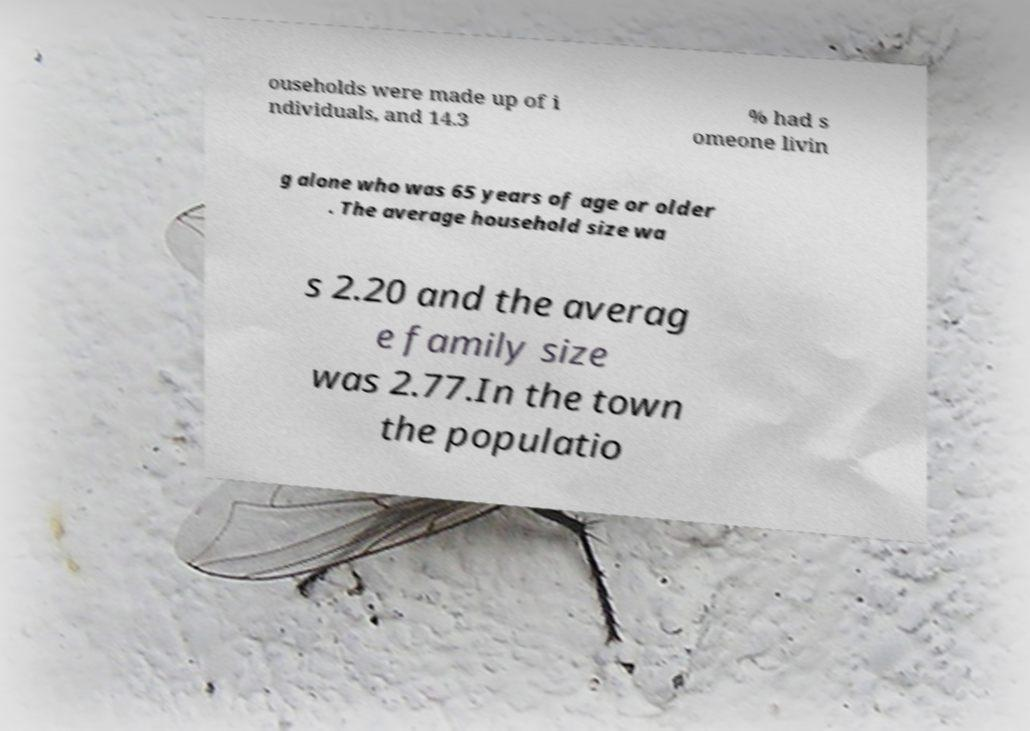What messages or text are displayed in this image? I need them in a readable, typed format. ouseholds were made up of i ndividuals, and 14.3 % had s omeone livin g alone who was 65 years of age or older . The average household size wa s 2.20 and the averag e family size was 2.77.In the town the populatio 